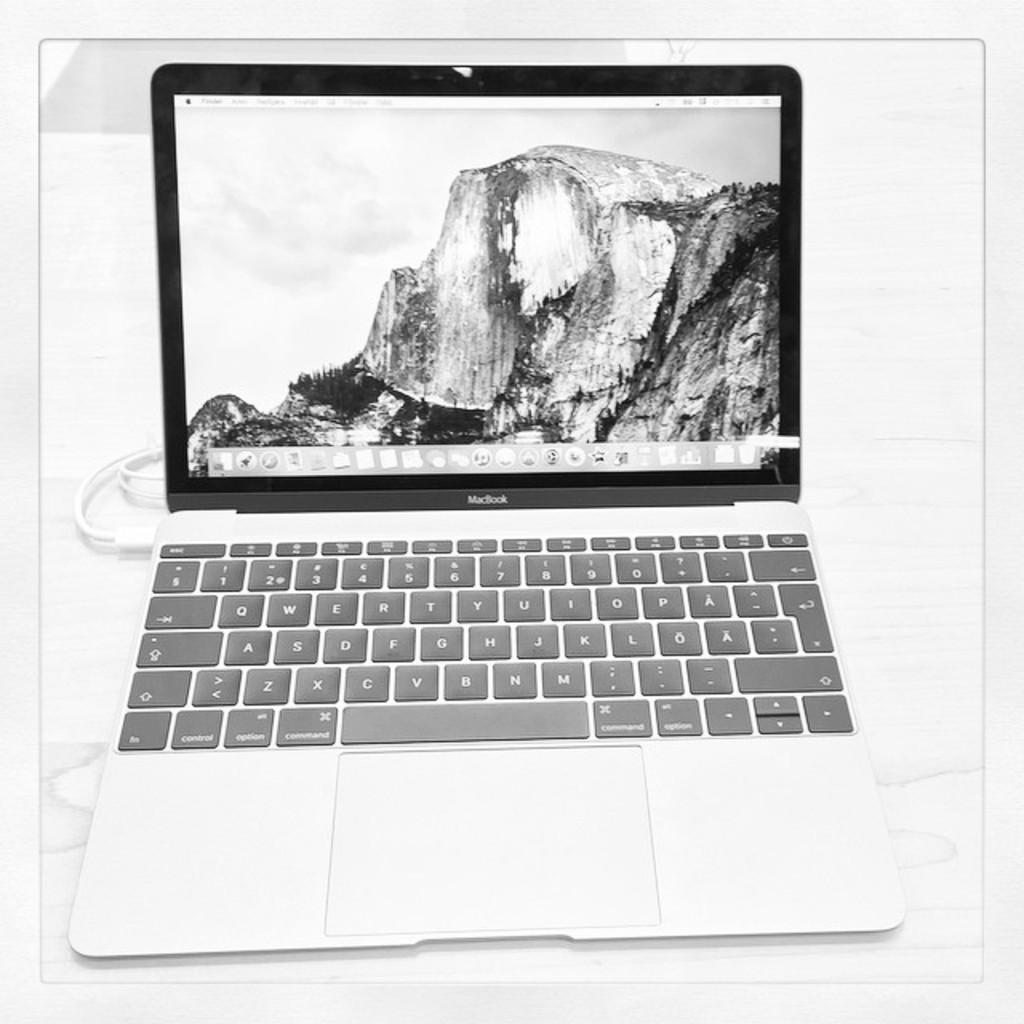What electronic device is visible in the image? There is a laptop in the image. Where is the laptop placed in the image? The laptop is on a platform. What type of government is depicted in the image? There is no depiction of a government in the image; it features a laptop on a platform. What color is the orange in the image? There is no orange present in the image. 